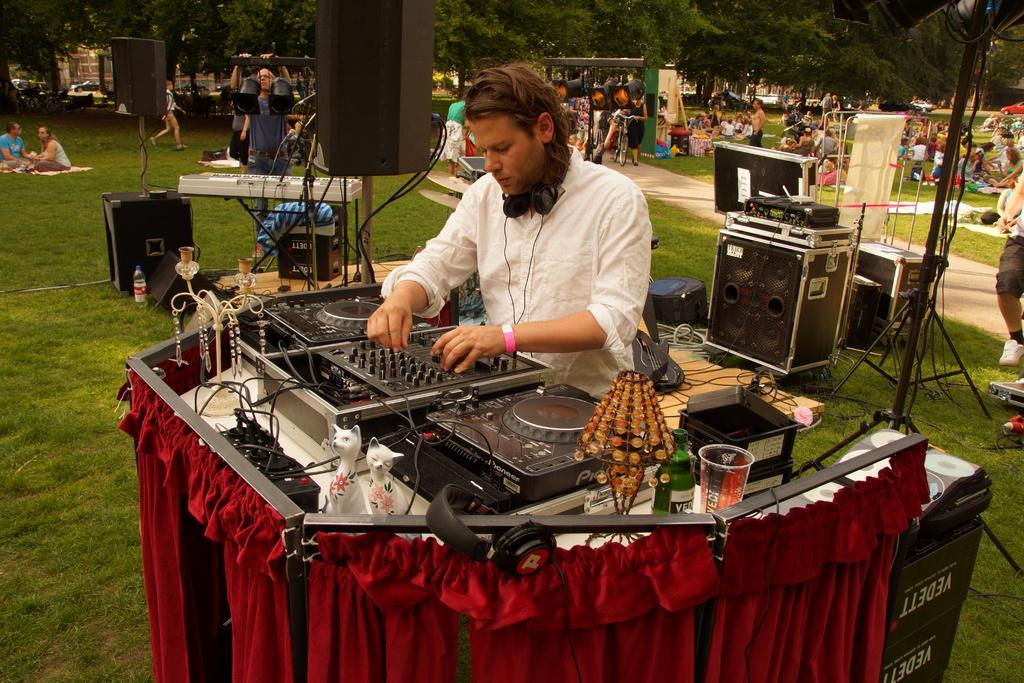Please provide a concise description of this image. In the background we can see the trees. In this picture we can see the people standing, walking and sitting. We can see some devices and some objects. We can see few objects on the floor. We can see a man, headphones around his neck. On a table we can see a glass, bottle, toys, few objects and devices. It seems like he is a DJ (Disc jockey) player. 